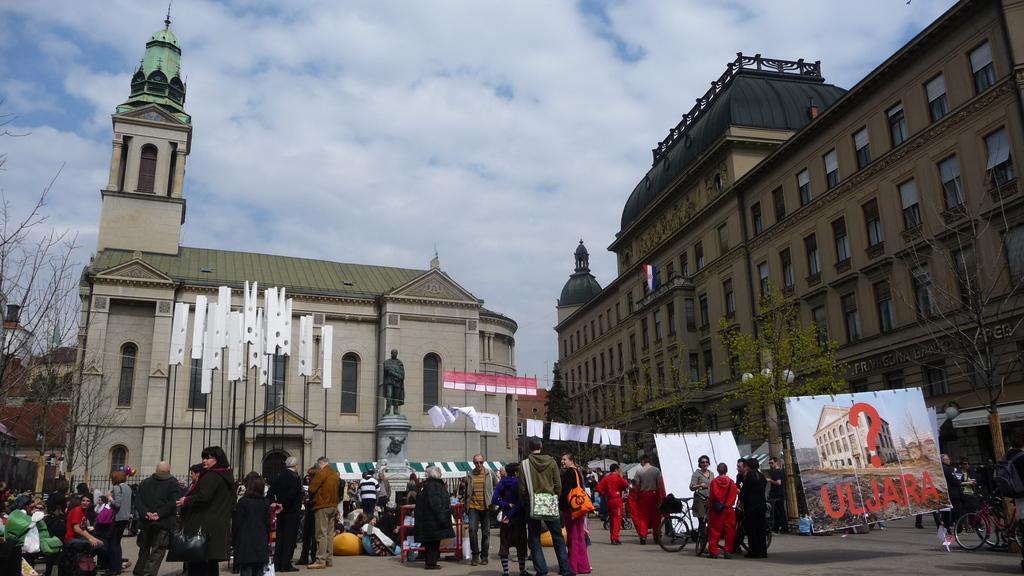In one or two sentences, can you explain what this image depicts? In this image we can see people, road, banners, statue, trees, bicycle, poles, lights, buildings, and other objects. In the background there is sky with clouds. 